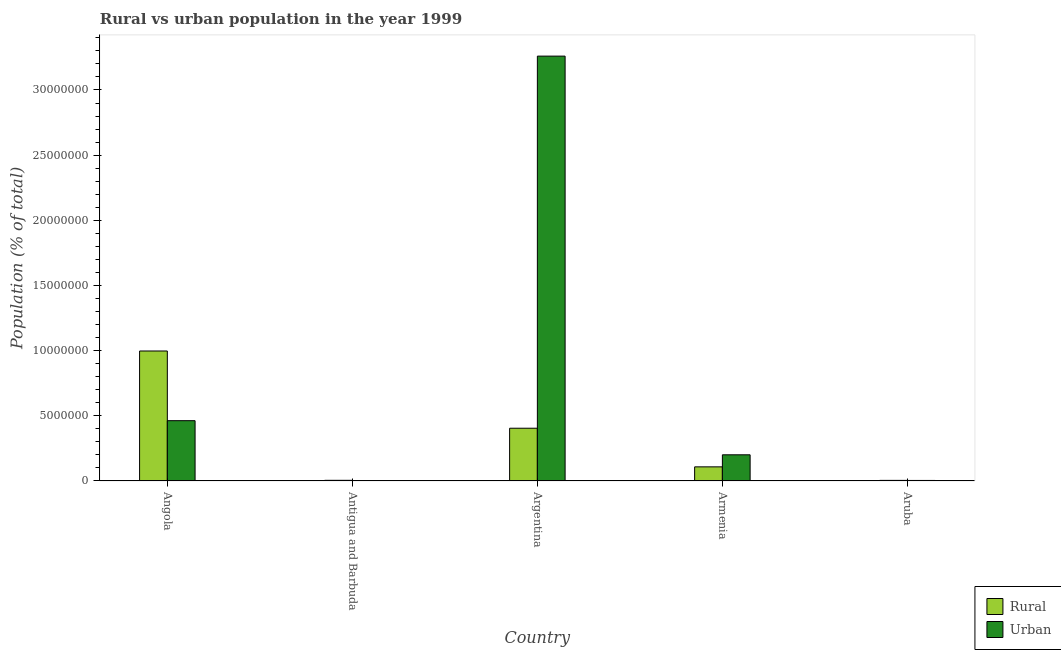How many different coloured bars are there?
Your response must be concise. 2. How many groups of bars are there?
Keep it short and to the point. 5. Are the number of bars per tick equal to the number of legend labels?
Offer a terse response. Yes. Are the number of bars on each tick of the X-axis equal?
Provide a succinct answer. Yes. What is the label of the 5th group of bars from the left?
Keep it short and to the point. Aruba. In how many cases, is the number of bars for a given country not equal to the number of legend labels?
Offer a terse response. 0. What is the rural population density in Armenia?
Make the answer very short. 1.08e+06. Across all countries, what is the maximum rural population density?
Ensure brevity in your answer.  9.97e+06. Across all countries, what is the minimum rural population density?
Your answer should be very brief. 4.71e+04. In which country was the rural population density minimum?
Your answer should be very brief. Aruba. What is the total urban population density in the graph?
Your response must be concise. 3.93e+07. What is the difference between the rural population density in Angola and that in Aruba?
Give a very brief answer. 9.93e+06. What is the difference between the rural population density in Argentina and the urban population density in Armenia?
Your answer should be compact. 2.04e+06. What is the average urban population density per country?
Offer a terse response. 7.86e+06. What is the difference between the rural population density and urban population density in Angola?
Keep it short and to the point. 5.35e+06. In how many countries, is the urban population density greater than 15000000 %?
Provide a succinct answer. 1. What is the ratio of the rural population density in Argentina to that in Armenia?
Keep it short and to the point. 3.73. What is the difference between the highest and the second highest rural population density?
Your answer should be very brief. 5.93e+06. What is the difference between the highest and the lowest rural population density?
Ensure brevity in your answer.  9.93e+06. Is the sum of the rural population density in Argentina and Aruba greater than the maximum urban population density across all countries?
Give a very brief answer. No. What does the 2nd bar from the left in Armenia represents?
Give a very brief answer. Urban. What does the 1st bar from the right in Aruba represents?
Your answer should be compact. Urban. How many countries are there in the graph?
Offer a terse response. 5. Are the values on the major ticks of Y-axis written in scientific E-notation?
Your answer should be compact. No. Does the graph contain any zero values?
Your response must be concise. No. Where does the legend appear in the graph?
Your response must be concise. Bottom right. How many legend labels are there?
Your answer should be compact. 2. What is the title of the graph?
Your answer should be compact. Rural vs urban population in the year 1999. Does "Female labourers" appear as one of the legend labels in the graph?
Keep it short and to the point. No. What is the label or title of the X-axis?
Your response must be concise. Country. What is the label or title of the Y-axis?
Make the answer very short. Population (% of total). What is the Population (% of total) of Rural in Angola?
Provide a succinct answer. 9.97e+06. What is the Population (% of total) in Urban in Angola?
Offer a terse response. 4.63e+06. What is the Population (% of total) of Rural in Antigua and Barbuda?
Your answer should be compact. 5.13e+04. What is the Population (% of total) of Urban in Antigua and Barbuda?
Your answer should be very brief. 2.47e+04. What is the Population (% of total) in Rural in Argentina?
Keep it short and to the point. 4.05e+06. What is the Population (% of total) of Urban in Argentina?
Offer a terse response. 3.26e+07. What is the Population (% of total) in Rural in Armenia?
Offer a very short reply. 1.08e+06. What is the Population (% of total) in Urban in Armenia?
Give a very brief answer. 2.01e+06. What is the Population (% of total) of Rural in Aruba?
Ensure brevity in your answer.  4.71e+04. What is the Population (% of total) in Urban in Aruba?
Give a very brief answer. 4.19e+04. Across all countries, what is the maximum Population (% of total) of Rural?
Provide a succinct answer. 9.97e+06. Across all countries, what is the maximum Population (% of total) of Urban?
Provide a short and direct response. 3.26e+07. Across all countries, what is the minimum Population (% of total) of Rural?
Provide a succinct answer. 4.71e+04. Across all countries, what is the minimum Population (% of total) of Urban?
Keep it short and to the point. 2.47e+04. What is the total Population (% of total) of Rural in the graph?
Your answer should be compact. 1.52e+07. What is the total Population (% of total) in Urban in the graph?
Ensure brevity in your answer.  3.93e+07. What is the difference between the Population (% of total) of Rural in Angola and that in Antigua and Barbuda?
Offer a terse response. 9.92e+06. What is the difference between the Population (% of total) in Urban in Angola and that in Antigua and Barbuda?
Make the answer very short. 4.60e+06. What is the difference between the Population (% of total) of Rural in Angola and that in Argentina?
Ensure brevity in your answer.  5.93e+06. What is the difference between the Population (% of total) in Urban in Angola and that in Argentina?
Give a very brief answer. -2.80e+07. What is the difference between the Population (% of total) in Rural in Angola and that in Armenia?
Provide a succinct answer. 8.89e+06. What is the difference between the Population (% of total) in Urban in Angola and that in Armenia?
Provide a short and direct response. 2.62e+06. What is the difference between the Population (% of total) in Rural in Angola and that in Aruba?
Provide a succinct answer. 9.93e+06. What is the difference between the Population (% of total) of Urban in Angola and that in Aruba?
Your response must be concise. 4.59e+06. What is the difference between the Population (% of total) of Rural in Antigua and Barbuda and that in Argentina?
Give a very brief answer. -4.00e+06. What is the difference between the Population (% of total) in Urban in Antigua and Barbuda and that in Argentina?
Give a very brief answer. -3.26e+07. What is the difference between the Population (% of total) in Rural in Antigua and Barbuda and that in Armenia?
Offer a very short reply. -1.03e+06. What is the difference between the Population (% of total) of Urban in Antigua and Barbuda and that in Armenia?
Your response must be concise. -1.98e+06. What is the difference between the Population (% of total) in Rural in Antigua and Barbuda and that in Aruba?
Ensure brevity in your answer.  4276. What is the difference between the Population (% of total) in Urban in Antigua and Barbuda and that in Aruba?
Your answer should be very brief. -1.72e+04. What is the difference between the Population (% of total) in Rural in Argentina and that in Armenia?
Offer a terse response. 2.96e+06. What is the difference between the Population (% of total) in Urban in Argentina and that in Armenia?
Your response must be concise. 3.06e+07. What is the difference between the Population (% of total) in Rural in Argentina and that in Aruba?
Provide a succinct answer. 4.00e+06. What is the difference between the Population (% of total) in Urban in Argentina and that in Aruba?
Provide a short and direct response. 3.26e+07. What is the difference between the Population (% of total) in Rural in Armenia and that in Aruba?
Offer a terse response. 1.04e+06. What is the difference between the Population (% of total) in Urban in Armenia and that in Aruba?
Ensure brevity in your answer.  1.97e+06. What is the difference between the Population (% of total) in Rural in Angola and the Population (% of total) in Urban in Antigua and Barbuda?
Provide a short and direct response. 9.95e+06. What is the difference between the Population (% of total) of Rural in Angola and the Population (% of total) of Urban in Argentina?
Provide a short and direct response. -2.26e+07. What is the difference between the Population (% of total) of Rural in Angola and the Population (% of total) of Urban in Armenia?
Keep it short and to the point. 7.96e+06. What is the difference between the Population (% of total) in Rural in Angola and the Population (% of total) in Urban in Aruba?
Provide a short and direct response. 9.93e+06. What is the difference between the Population (% of total) of Rural in Antigua and Barbuda and the Population (% of total) of Urban in Argentina?
Offer a very short reply. -3.25e+07. What is the difference between the Population (% of total) of Rural in Antigua and Barbuda and the Population (% of total) of Urban in Armenia?
Ensure brevity in your answer.  -1.96e+06. What is the difference between the Population (% of total) of Rural in Antigua and Barbuda and the Population (% of total) of Urban in Aruba?
Your answer should be very brief. 9390. What is the difference between the Population (% of total) of Rural in Argentina and the Population (% of total) of Urban in Armenia?
Your answer should be compact. 2.04e+06. What is the difference between the Population (% of total) of Rural in Argentina and the Population (% of total) of Urban in Aruba?
Your answer should be compact. 4.01e+06. What is the difference between the Population (% of total) in Rural in Armenia and the Population (% of total) in Urban in Aruba?
Your response must be concise. 1.04e+06. What is the average Population (% of total) of Rural per country?
Your answer should be very brief. 3.04e+06. What is the average Population (% of total) of Urban per country?
Your answer should be very brief. 7.86e+06. What is the difference between the Population (% of total) in Rural and Population (% of total) in Urban in Angola?
Keep it short and to the point. 5.35e+06. What is the difference between the Population (% of total) in Rural and Population (% of total) in Urban in Antigua and Barbuda?
Ensure brevity in your answer.  2.66e+04. What is the difference between the Population (% of total) of Rural and Population (% of total) of Urban in Argentina?
Keep it short and to the point. -2.86e+07. What is the difference between the Population (% of total) of Rural and Population (% of total) of Urban in Armenia?
Your answer should be very brief. -9.25e+05. What is the difference between the Population (% of total) in Rural and Population (% of total) in Urban in Aruba?
Keep it short and to the point. 5114. What is the ratio of the Population (% of total) in Rural in Angola to that in Antigua and Barbuda?
Your response must be concise. 194.3. What is the ratio of the Population (% of total) in Urban in Angola to that in Antigua and Barbuda?
Provide a succinct answer. 187.31. What is the ratio of the Population (% of total) of Rural in Angola to that in Argentina?
Make the answer very short. 2.46. What is the ratio of the Population (% of total) in Urban in Angola to that in Argentina?
Make the answer very short. 0.14. What is the ratio of the Population (% of total) of Rural in Angola to that in Armenia?
Ensure brevity in your answer.  9.2. What is the ratio of the Population (% of total) of Urban in Angola to that in Armenia?
Keep it short and to the point. 2.3. What is the ratio of the Population (% of total) in Rural in Angola to that in Aruba?
Provide a succinct answer. 211.95. What is the ratio of the Population (% of total) of Urban in Angola to that in Aruba?
Keep it short and to the point. 110.33. What is the ratio of the Population (% of total) of Rural in Antigua and Barbuda to that in Argentina?
Your answer should be compact. 0.01. What is the ratio of the Population (% of total) of Urban in Antigua and Barbuda to that in Argentina?
Your answer should be compact. 0. What is the ratio of the Population (% of total) of Rural in Antigua and Barbuda to that in Armenia?
Provide a short and direct response. 0.05. What is the ratio of the Population (% of total) of Urban in Antigua and Barbuda to that in Armenia?
Give a very brief answer. 0.01. What is the ratio of the Population (% of total) in Urban in Antigua and Barbuda to that in Aruba?
Your response must be concise. 0.59. What is the ratio of the Population (% of total) in Rural in Argentina to that in Armenia?
Your response must be concise. 3.73. What is the ratio of the Population (% of total) in Urban in Argentina to that in Armenia?
Give a very brief answer. 16.22. What is the ratio of the Population (% of total) in Rural in Argentina to that in Aruba?
Your answer should be compact. 86.04. What is the ratio of the Population (% of total) in Urban in Argentina to that in Aruba?
Offer a very short reply. 777.19. What is the ratio of the Population (% of total) in Rural in Armenia to that in Aruba?
Your answer should be very brief. 23.05. What is the ratio of the Population (% of total) of Urban in Armenia to that in Aruba?
Provide a succinct answer. 47.9. What is the difference between the highest and the second highest Population (% of total) of Rural?
Provide a succinct answer. 5.93e+06. What is the difference between the highest and the second highest Population (% of total) in Urban?
Provide a short and direct response. 2.80e+07. What is the difference between the highest and the lowest Population (% of total) in Rural?
Your response must be concise. 9.93e+06. What is the difference between the highest and the lowest Population (% of total) in Urban?
Ensure brevity in your answer.  3.26e+07. 